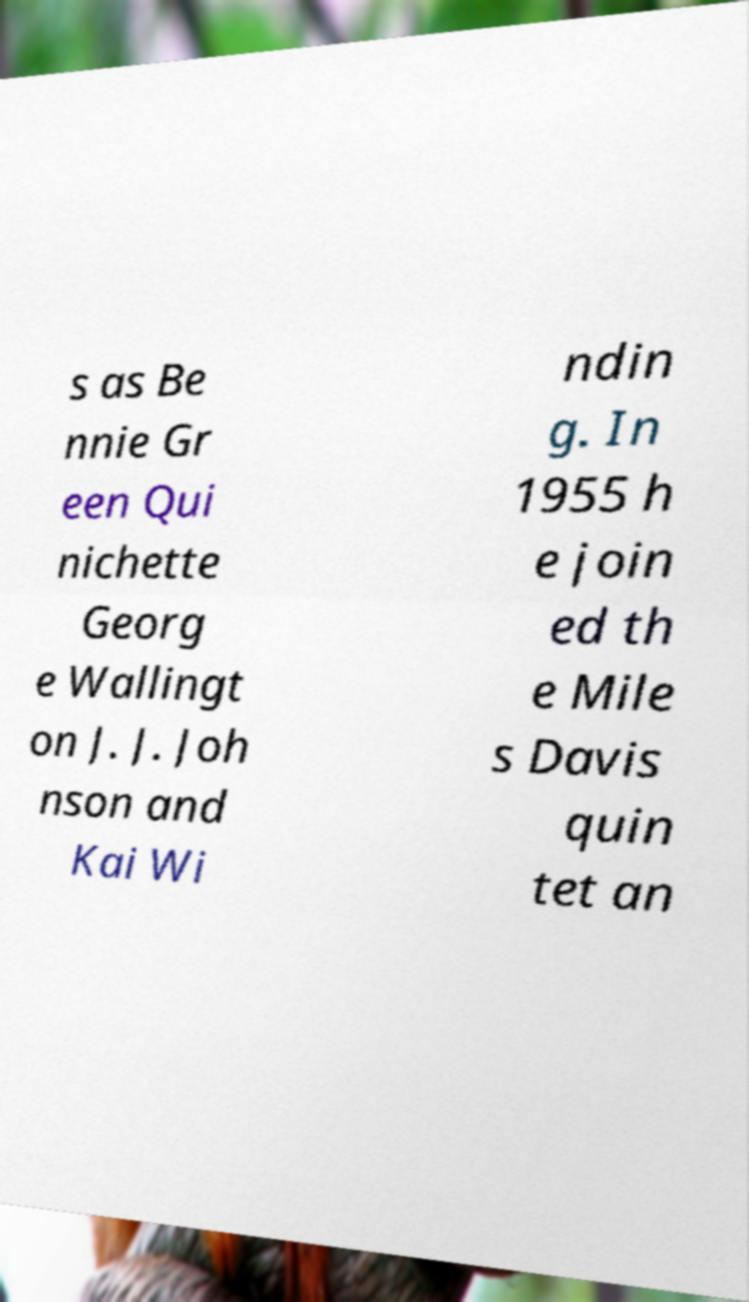Could you extract and type out the text from this image? s as Be nnie Gr een Qui nichette Georg e Wallingt on J. J. Joh nson and Kai Wi ndin g. In 1955 h e join ed th e Mile s Davis quin tet an 